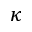Convert formula to latex. <formula><loc_0><loc_0><loc_500><loc_500>\kappa</formula> 